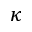Convert formula to latex. <formula><loc_0><loc_0><loc_500><loc_500>\kappa</formula> 